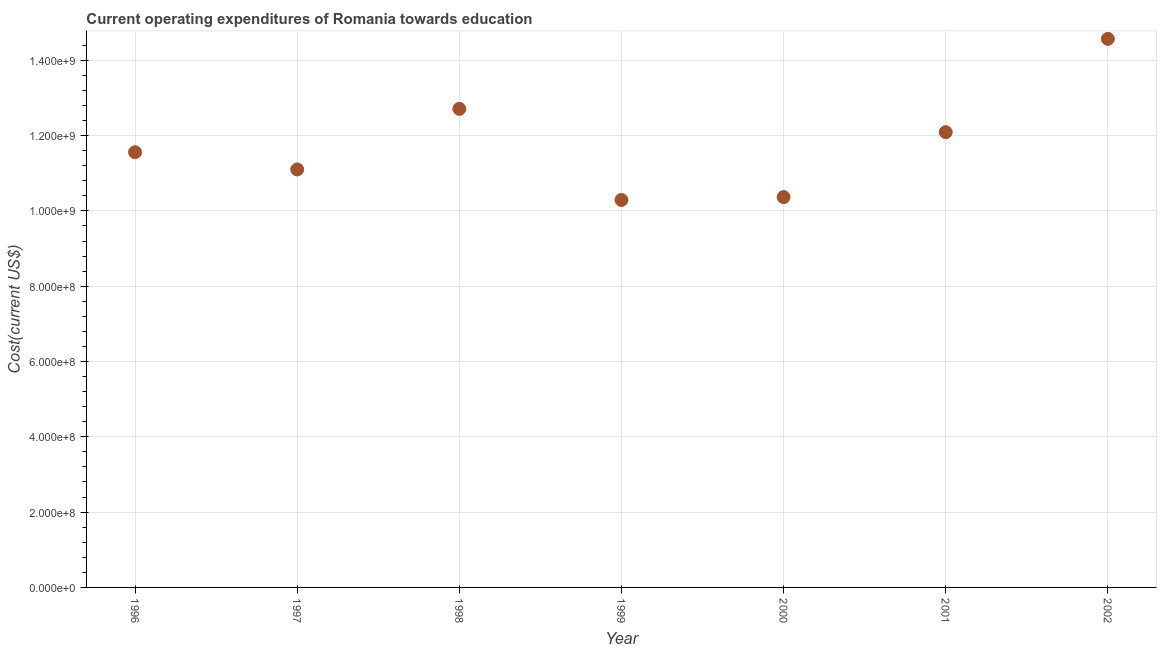What is the education expenditure in 1997?
Your answer should be very brief. 1.11e+09. Across all years, what is the maximum education expenditure?
Offer a very short reply. 1.46e+09. Across all years, what is the minimum education expenditure?
Give a very brief answer. 1.03e+09. What is the sum of the education expenditure?
Your answer should be very brief. 8.27e+09. What is the difference between the education expenditure in 2001 and 2002?
Offer a terse response. -2.48e+08. What is the average education expenditure per year?
Offer a terse response. 1.18e+09. What is the median education expenditure?
Give a very brief answer. 1.16e+09. In how many years, is the education expenditure greater than 880000000 US$?
Your answer should be very brief. 7. What is the ratio of the education expenditure in 1997 to that in 2002?
Your response must be concise. 0.76. Is the education expenditure in 1998 less than that in 2001?
Ensure brevity in your answer.  No. Is the difference between the education expenditure in 1996 and 2002 greater than the difference between any two years?
Keep it short and to the point. No. What is the difference between the highest and the second highest education expenditure?
Your answer should be compact. 1.86e+08. What is the difference between the highest and the lowest education expenditure?
Provide a short and direct response. 4.28e+08. Does the education expenditure monotonically increase over the years?
Your response must be concise. No. What is the difference between two consecutive major ticks on the Y-axis?
Ensure brevity in your answer.  2.00e+08. Does the graph contain any zero values?
Provide a short and direct response. No. Does the graph contain grids?
Give a very brief answer. Yes. What is the title of the graph?
Your answer should be very brief. Current operating expenditures of Romania towards education. What is the label or title of the X-axis?
Make the answer very short. Year. What is the label or title of the Y-axis?
Ensure brevity in your answer.  Cost(current US$). What is the Cost(current US$) in 1996?
Offer a terse response. 1.16e+09. What is the Cost(current US$) in 1997?
Offer a terse response. 1.11e+09. What is the Cost(current US$) in 1998?
Provide a short and direct response. 1.27e+09. What is the Cost(current US$) in 1999?
Give a very brief answer. 1.03e+09. What is the Cost(current US$) in 2000?
Give a very brief answer. 1.04e+09. What is the Cost(current US$) in 2001?
Your answer should be compact. 1.21e+09. What is the Cost(current US$) in 2002?
Keep it short and to the point. 1.46e+09. What is the difference between the Cost(current US$) in 1996 and 1997?
Offer a very short reply. 4.57e+07. What is the difference between the Cost(current US$) in 1996 and 1998?
Your answer should be very brief. -1.15e+08. What is the difference between the Cost(current US$) in 1996 and 1999?
Offer a very short reply. 1.27e+08. What is the difference between the Cost(current US$) in 1996 and 2000?
Make the answer very short. 1.19e+08. What is the difference between the Cost(current US$) in 1996 and 2001?
Make the answer very short. -5.33e+07. What is the difference between the Cost(current US$) in 1996 and 2002?
Keep it short and to the point. -3.01e+08. What is the difference between the Cost(current US$) in 1997 and 1998?
Make the answer very short. -1.61e+08. What is the difference between the Cost(current US$) in 1997 and 1999?
Your response must be concise. 8.10e+07. What is the difference between the Cost(current US$) in 1997 and 2000?
Make the answer very short. 7.34e+07. What is the difference between the Cost(current US$) in 1997 and 2001?
Your answer should be compact. -9.90e+07. What is the difference between the Cost(current US$) in 1997 and 2002?
Ensure brevity in your answer.  -3.47e+08. What is the difference between the Cost(current US$) in 1998 and 1999?
Keep it short and to the point. 2.42e+08. What is the difference between the Cost(current US$) in 1998 and 2000?
Give a very brief answer. 2.34e+08. What is the difference between the Cost(current US$) in 1998 and 2001?
Your answer should be very brief. 6.19e+07. What is the difference between the Cost(current US$) in 1998 and 2002?
Provide a short and direct response. -1.86e+08. What is the difference between the Cost(current US$) in 1999 and 2000?
Provide a short and direct response. -7.63e+06. What is the difference between the Cost(current US$) in 1999 and 2001?
Ensure brevity in your answer.  -1.80e+08. What is the difference between the Cost(current US$) in 1999 and 2002?
Give a very brief answer. -4.28e+08. What is the difference between the Cost(current US$) in 2000 and 2001?
Keep it short and to the point. -1.72e+08. What is the difference between the Cost(current US$) in 2000 and 2002?
Your answer should be compact. -4.20e+08. What is the difference between the Cost(current US$) in 2001 and 2002?
Provide a short and direct response. -2.48e+08. What is the ratio of the Cost(current US$) in 1996 to that in 1997?
Provide a short and direct response. 1.04. What is the ratio of the Cost(current US$) in 1996 to that in 1998?
Ensure brevity in your answer.  0.91. What is the ratio of the Cost(current US$) in 1996 to that in 1999?
Offer a very short reply. 1.12. What is the ratio of the Cost(current US$) in 1996 to that in 2000?
Provide a succinct answer. 1.11. What is the ratio of the Cost(current US$) in 1996 to that in 2001?
Your response must be concise. 0.96. What is the ratio of the Cost(current US$) in 1996 to that in 2002?
Offer a terse response. 0.79. What is the ratio of the Cost(current US$) in 1997 to that in 1998?
Offer a terse response. 0.87. What is the ratio of the Cost(current US$) in 1997 to that in 1999?
Your answer should be very brief. 1.08. What is the ratio of the Cost(current US$) in 1997 to that in 2000?
Give a very brief answer. 1.07. What is the ratio of the Cost(current US$) in 1997 to that in 2001?
Provide a succinct answer. 0.92. What is the ratio of the Cost(current US$) in 1997 to that in 2002?
Offer a terse response. 0.76. What is the ratio of the Cost(current US$) in 1998 to that in 1999?
Make the answer very short. 1.24. What is the ratio of the Cost(current US$) in 1998 to that in 2000?
Make the answer very short. 1.23. What is the ratio of the Cost(current US$) in 1998 to that in 2001?
Provide a succinct answer. 1.05. What is the ratio of the Cost(current US$) in 1998 to that in 2002?
Make the answer very short. 0.87. What is the ratio of the Cost(current US$) in 1999 to that in 2001?
Ensure brevity in your answer.  0.85. What is the ratio of the Cost(current US$) in 1999 to that in 2002?
Your answer should be compact. 0.71. What is the ratio of the Cost(current US$) in 2000 to that in 2001?
Your answer should be very brief. 0.86. What is the ratio of the Cost(current US$) in 2000 to that in 2002?
Offer a terse response. 0.71. What is the ratio of the Cost(current US$) in 2001 to that in 2002?
Ensure brevity in your answer.  0.83. 